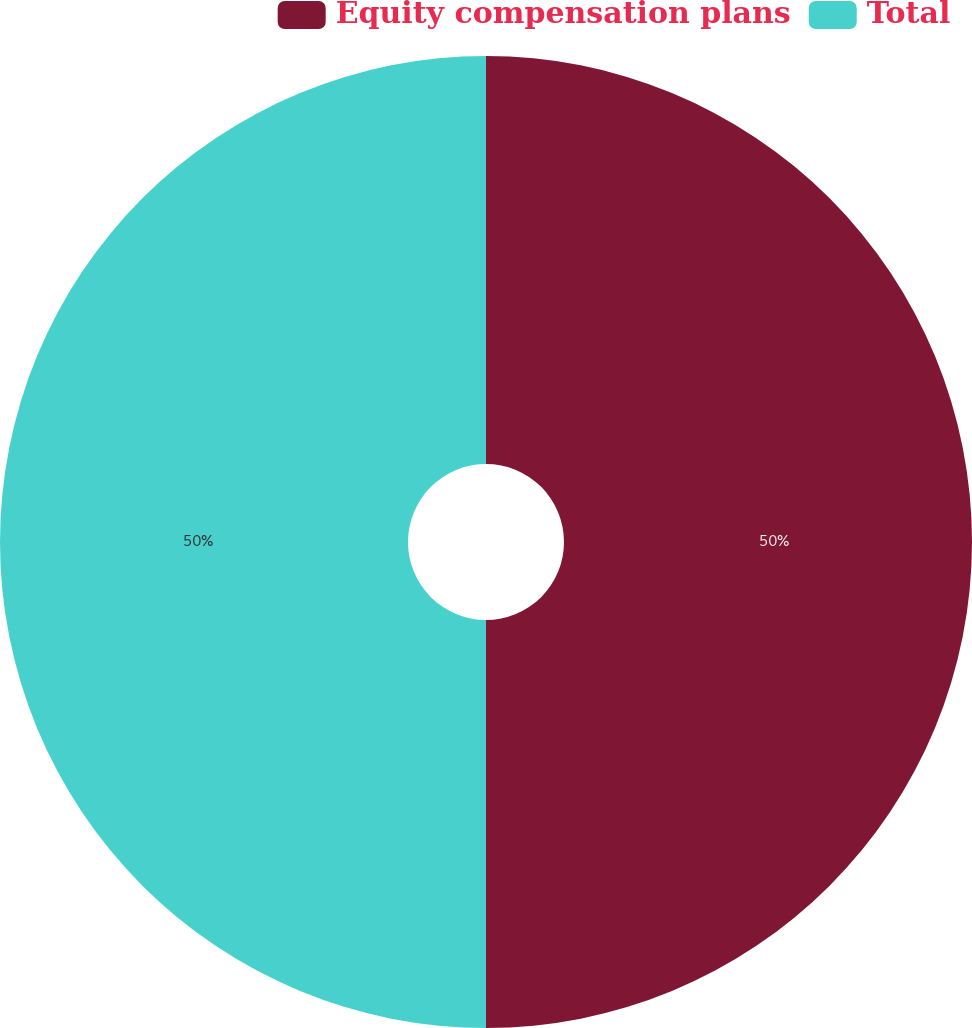Convert chart to OTSL. <chart><loc_0><loc_0><loc_500><loc_500><pie_chart><fcel>Equity compensation plans<fcel>Total<nl><fcel>50.0%<fcel>50.0%<nl></chart> 